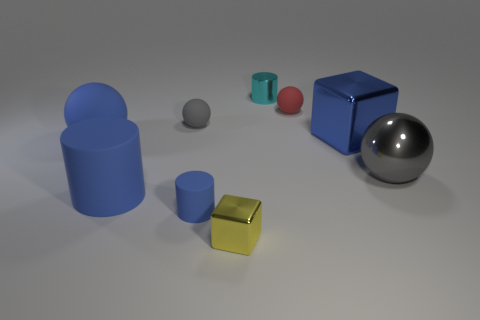What is the shape of the yellow shiny thing that is right of the tiny gray rubber sphere?
Your answer should be compact. Cube. What number of big blue things have the same shape as the yellow metallic thing?
Provide a short and direct response. 1. What is the size of the gray object that is left of the tiny shiny thing that is in front of the tiny cyan shiny object?
Provide a succinct answer. Small. How many yellow things are either metallic spheres or cubes?
Offer a very short reply. 1. Is the number of tiny yellow blocks behind the metal cylinder less than the number of blue things that are in front of the big matte sphere?
Make the answer very short. Yes. Is the size of the yellow metal object the same as the gray thing behind the big blue sphere?
Your answer should be very brief. Yes. What number of other cyan cylinders have the same size as the cyan metallic cylinder?
Your response must be concise. 0. How many small objects are either blue shiny blocks or yellow matte balls?
Make the answer very short. 0. Is there a tiny ball?
Your answer should be compact. Yes. Is the number of tiny red balls that are left of the cyan cylinder greater than the number of tiny cyan metal things to the left of the small yellow shiny cube?
Offer a terse response. No. 